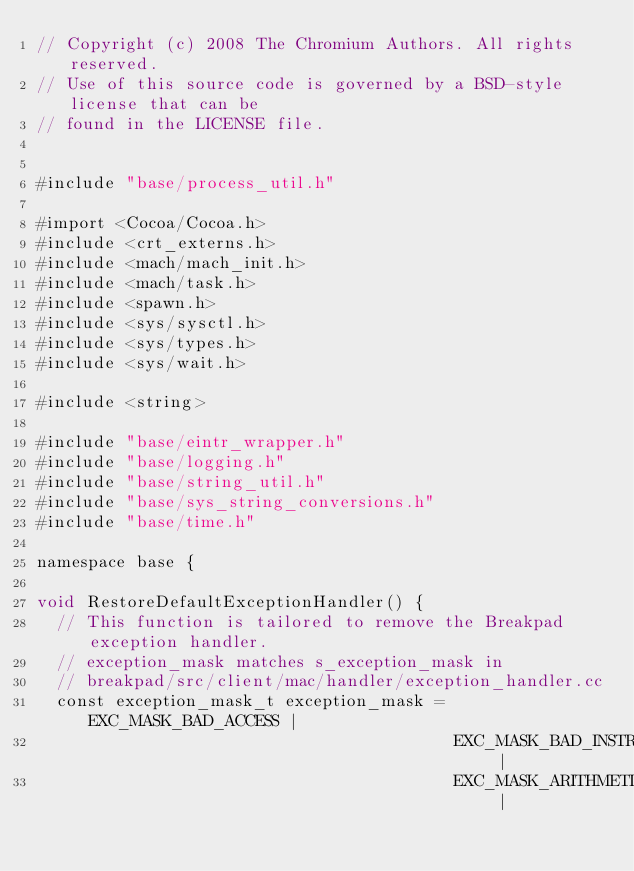Convert code to text. <code><loc_0><loc_0><loc_500><loc_500><_ObjectiveC_>// Copyright (c) 2008 The Chromium Authors. All rights reserved.
// Use of this source code is governed by a BSD-style license that can be
// found in the LICENSE file.


#include "base/process_util.h"

#import <Cocoa/Cocoa.h>
#include <crt_externs.h>
#include <mach/mach_init.h>
#include <mach/task.h>
#include <spawn.h>
#include <sys/sysctl.h>
#include <sys/types.h>
#include <sys/wait.h>

#include <string>

#include "base/eintr_wrapper.h"
#include "base/logging.h"
#include "base/string_util.h"
#include "base/sys_string_conversions.h"
#include "base/time.h"

namespace base {

void RestoreDefaultExceptionHandler() {
  // This function is tailored to remove the Breakpad exception handler.
  // exception_mask matches s_exception_mask in
  // breakpad/src/client/mac/handler/exception_handler.cc
  const exception_mask_t exception_mask = EXC_MASK_BAD_ACCESS |
                                          EXC_MASK_BAD_INSTRUCTION |
                                          EXC_MASK_ARITHMETIC |</code> 